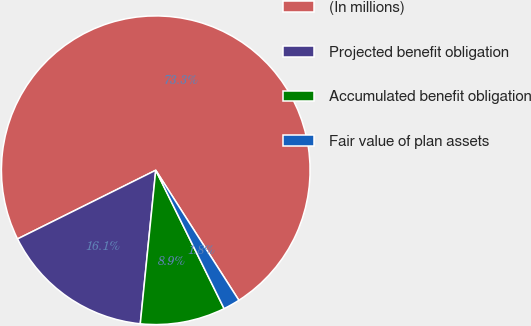Convert chart to OTSL. <chart><loc_0><loc_0><loc_500><loc_500><pie_chart><fcel>(In millions)<fcel>Projected benefit obligation<fcel>Accumulated benefit obligation<fcel>Fair value of plan assets<nl><fcel>73.29%<fcel>16.06%<fcel>8.9%<fcel>1.75%<nl></chart> 